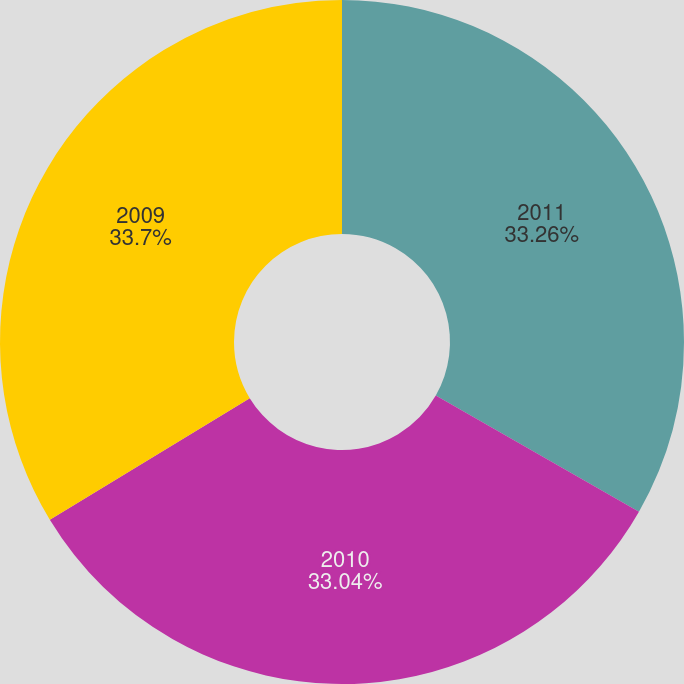Convert chart to OTSL. <chart><loc_0><loc_0><loc_500><loc_500><pie_chart><fcel>2011<fcel>2010<fcel>2009<nl><fcel>33.26%<fcel>33.04%<fcel>33.7%<nl></chart> 